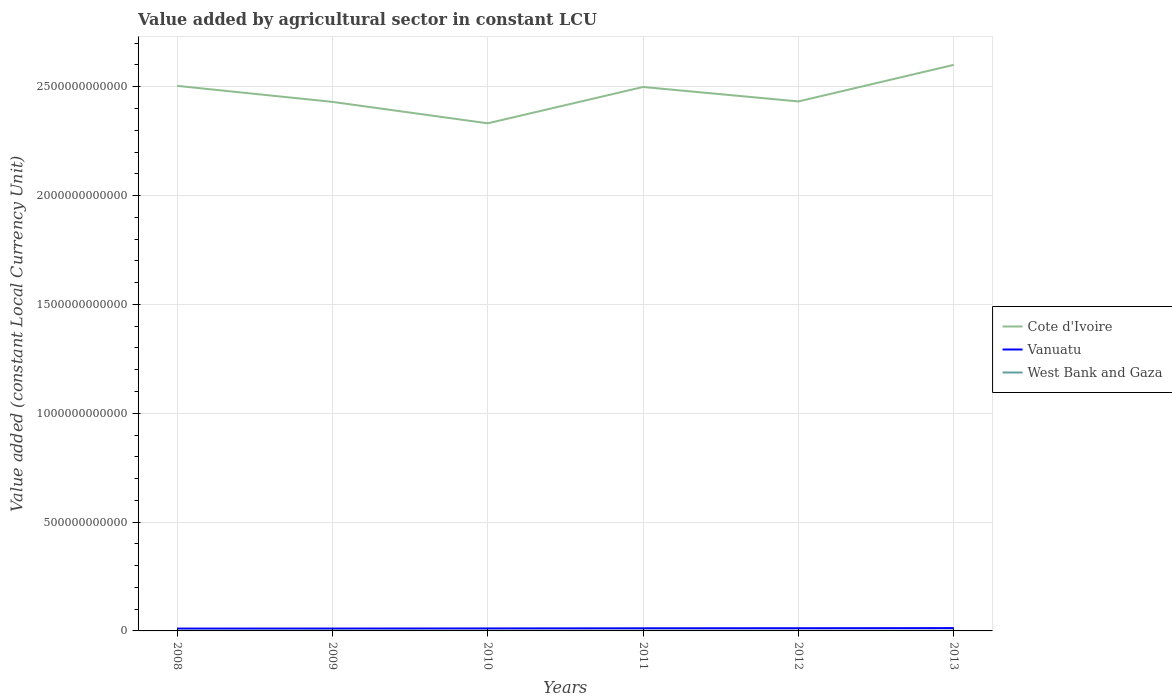Is the number of lines equal to the number of legend labels?
Give a very brief answer. Yes. Across all years, what is the maximum value added by agricultural sector in West Bank and Gaza?
Keep it short and to the point. 1.12e+09. What is the total value added by agricultural sector in Vanuatu in the graph?
Give a very brief answer. -1.56e+09. What is the difference between the highest and the second highest value added by agricultural sector in West Bank and Gaza?
Offer a terse response. 3.44e+08. Is the value added by agricultural sector in Cote d'Ivoire strictly greater than the value added by agricultural sector in Vanuatu over the years?
Provide a short and direct response. No. How many years are there in the graph?
Give a very brief answer. 6. What is the difference between two consecutive major ticks on the Y-axis?
Keep it short and to the point. 5.00e+11. Does the graph contain any zero values?
Keep it short and to the point. No. Does the graph contain grids?
Make the answer very short. Yes. Where does the legend appear in the graph?
Provide a short and direct response. Center right. How are the legend labels stacked?
Your response must be concise. Vertical. What is the title of the graph?
Offer a very short reply. Value added by agricultural sector in constant LCU. Does "Vietnam" appear as one of the legend labels in the graph?
Ensure brevity in your answer.  No. What is the label or title of the Y-axis?
Provide a succinct answer. Value added (constant Local Currency Unit). What is the Value added (constant Local Currency Unit) in Cote d'Ivoire in 2008?
Ensure brevity in your answer.  2.50e+12. What is the Value added (constant Local Currency Unit) in Vanuatu in 2008?
Ensure brevity in your answer.  1.08e+1. What is the Value added (constant Local Currency Unit) in West Bank and Gaza in 2008?
Your response must be concise. 1.19e+09. What is the Value added (constant Local Currency Unit) of Cote d'Ivoire in 2009?
Provide a short and direct response. 2.43e+12. What is the Value added (constant Local Currency Unit) in Vanuatu in 2009?
Offer a terse response. 1.09e+1. What is the Value added (constant Local Currency Unit) in West Bank and Gaza in 2009?
Make the answer very short. 1.37e+09. What is the Value added (constant Local Currency Unit) of Cote d'Ivoire in 2010?
Offer a very short reply. 2.33e+12. What is the Value added (constant Local Currency Unit) of Vanuatu in 2010?
Offer a terse response. 1.14e+1. What is the Value added (constant Local Currency Unit) of West Bank and Gaza in 2010?
Offer a terse response. 1.24e+09. What is the Value added (constant Local Currency Unit) in Cote d'Ivoire in 2011?
Ensure brevity in your answer.  2.50e+12. What is the Value added (constant Local Currency Unit) in Vanuatu in 2011?
Offer a terse response. 1.21e+1. What is the Value added (constant Local Currency Unit) of West Bank and Gaza in 2011?
Make the answer very short. 1.46e+09. What is the Value added (constant Local Currency Unit) in Cote d'Ivoire in 2012?
Ensure brevity in your answer.  2.43e+12. What is the Value added (constant Local Currency Unit) of Vanuatu in 2012?
Offer a very short reply. 1.24e+1. What is the Value added (constant Local Currency Unit) in West Bank and Gaza in 2012?
Your answer should be very brief. 1.31e+09. What is the Value added (constant Local Currency Unit) in Cote d'Ivoire in 2013?
Offer a terse response. 2.60e+12. What is the Value added (constant Local Currency Unit) of Vanuatu in 2013?
Provide a short and direct response. 1.30e+1. What is the Value added (constant Local Currency Unit) of West Bank and Gaza in 2013?
Your response must be concise. 1.12e+09. Across all years, what is the maximum Value added (constant Local Currency Unit) of Cote d'Ivoire?
Keep it short and to the point. 2.60e+12. Across all years, what is the maximum Value added (constant Local Currency Unit) in Vanuatu?
Keep it short and to the point. 1.30e+1. Across all years, what is the maximum Value added (constant Local Currency Unit) in West Bank and Gaza?
Ensure brevity in your answer.  1.46e+09. Across all years, what is the minimum Value added (constant Local Currency Unit) of Cote d'Ivoire?
Offer a very short reply. 2.33e+12. Across all years, what is the minimum Value added (constant Local Currency Unit) of Vanuatu?
Make the answer very short. 1.08e+1. Across all years, what is the minimum Value added (constant Local Currency Unit) of West Bank and Gaza?
Your response must be concise. 1.12e+09. What is the total Value added (constant Local Currency Unit) of Cote d'Ivoire in the graph?
Provide a succinct answer. 1.48e+13. What is the total Value added (constant Local Currency Unit) of Vanuatu in the graph?
Your answer should be compact. 7.06e+1. What is the total Value added (constant Local Currency Unit) of West Bank and Gaza in the graph?
Offer a terse response. 7.69e+09. What is the difference between the Value added (constant Local Currency Unit) of Cote d'Ivoire in 2008 and that in 2009?
Your answer should be very brief. 7.36e+1. What is the difference between the Value added (constant Local Currency Unit) in Vanuatu in 2008 and that in 2009?
Give a very brief answer. -7.10e+07. What is the difference between the Value added (constant Local Currency Unit) of West Bank and Gaza in 2008 and that in 2009?
Your answer should be compact. -1.77e+08. What is the difference between the Value added (constant Local Currency Unit) in Cote d'Ivoire in 2008 and that in 2010?
Give a very brief answer. 1.72e+11. What is the difference between the Value added (constant Local Currency Unit) of Vanuatu in 2008 and that in 2010?
Ensure brevity in your answer.  -5.96e+08. What is the difference between the Value added (constant Local Currency Unit) in West Bank and Gaza in 2008 and that in 2010?
Provide a succinct answer. -4.91e+07. What is the difference between the Value added (constant Local Currency Unit) of Cote d'Ivoire in 2008 and that in 2011?
Give a very brief answer. 5.21e+09. What is the difference between the Value added (constant Local Currency Unit) of Vanuatu in 2008 and that in 2011?
Give a very brief answer. -1.29e+09. What is the difference between the Value added (constant Local Currency Unit) in West Bank and Gaza in 2008 and that in 2011?
Ensure brevity in your answer.  -2.71e+08. What is the difference between the Value added (constant Local Currency Unit) of Cote d'Ivoire in 2008 and that in 2012?
Your response must be concise. 7.16e+1. What is the difference between the Value added (constant Local Currency Unit) in Vanuatu in 2008 and that in 2012?
Give a very brief answer. -1.56e+09. What is the difference between the Value added (constant Local Currency Unit) in West Bank and Gaza in 2008 and that in 2012?
Provide a succinct answer. -1.13e+08. What is the difference between the Value added (constant Local Currency Unit) of Cote d'Ivoire in 2008 and that in 2013?
Offer a very short reply. -9.64e+1. What is the difference between the Value added (constant Local Currency Unit) in Vanuatu in 2008 and that in 2013?
Provide a succinct answer. -2.15e+09. What is the difference between the Value added (constant Local Currency Unit) in West Bank and Gaza in 2008 and that in 2013?
Your answer should be very brief. 7.39e+07. What is the difference between the Value added (constant Local Currency Unit) in Cote d'Ivoire in 2009 and that in 2010?
Provide a succinct answer. 9.84e+1. What is the difference between the Value added (constant Local Currency Unit) in Vanuatu in 2009 and that in 2010?
Make the answer very short. -5.25e+08. What is the difference between the Value added (constant Local Currency Unit) in West Bank and Gaza in 2009 and that in 2010?
Your answer should be compact. 1.27e+08. What is the difference between the Value added (constant Local Currency Unit) of Cote d'Ivoire in 2009 and that in 2011?
Provide a short and direct response. -6.84e+1. What is the difference between the Value added (constant Local Currency Unit) in Vanuatu in 2009 and that in 2011?
Your response must be concise. -1.22e+09. What is the difference between the Value added (constant Local Currency Unit) in West Bank and Gaza in 2009 and that in 2011?
Your answer should be very brief. -9.40e+07. What is the difference between the Value added (constant Local Currency Unit) of Cote d'Ivoire in 2009 and that in 2012?
Your answer should be very brief. -2.03e+09. What is the difference between the Value added (constant Local Currency Unit) in Vanuatu in 2009 and that in 2012?
Provide a succinct answer. -1.49e+09. What is the difference between the Value added (constant Local Currency Unit) in West Bank and Gaza in 2009 and that in 2012?
Provide a succinct answer. 6.36e+07. What is the difference between the Value added (constant Local Currency Unit) of Cote d'Ivoire in 2009 and that in 2013?
Ensure brevity in your answer.  -1.70e+11. What is the difference between the Value added (constant Local Currency Unit) of Vanuatu in 2009 and that in 2013?
Offer a terse response. -2.08e+09. What is the difference between the Value added (constant Local Currency Unit) in West Bank and Gaza in 2009 and that in 2013?
Provide a short and direct response. 2.50e+08. What is the difference between the Value added (constant Local Currency Unit) of Cote d'Ivoire in 2010 and that in 2011?
Your response must be concise. -1.67e+11. What is the difference between the Value added (constant Local Currency Unit) in Vanuatu in 2010 and that in 2011?
Your response must be concise. -6.93e+08. What is the difference between the Value added (constant Local Currency Unit) of West Bank and Gaza in 2010 and that in 2011?
Offer a terse response. -2.21e+08. What is the difference between the Value added (constant Local Currency Unit) of Cote d'Ivoire in 2010 and that in 2012?
Make the answer very short. -1.00e+11. What is the difference between the Value added (constant Local Currency Unit) in Vanuatu in 2010 and that in 2012?
Ensure brevity in your answer.  -9.62e+08. What is the difference between the Value added (constant Local Currency Unit) in West Bank and Gaza in 2010 and that in 2012?
Your answer should be very brief. -6.38e+07. What is the difference between the Value added (constant Local Currency Unit) of Cote d'Ivoire in 2010 and that in 2013?
Provide a short and direct response. -2.68e+11. What is the difference between the Value added (constant Local Currency Unit) of Vanuatu in 2010 and that in 2013?
Ensure brevity in your answer.  -1.55e+09. What is the difference between the Value added (constant Local Currency Unit) of West Bank and Gaza in 2010 and that in 2013?
Give a very brief answer. 1.23e+08. What is the difference between the Value added (constant Local Currency Unit) in Cote d'Ivoire in 2011 and that in 2012?
Keep it short and to the point. 6.64e+1. What is the difference between the Value added (constant Local Currency Unit) of Vanuatu in 2011 and that in 2012?
Provide a short and direct response. -2.69e+08. What is the difference between the Value added (constant Local Currency Unit) of West Bank and Gaza in 2011 and that in 2012?
Ensure brevity in your answer.  1.58e+08. What is the difference between the Value added (constant Local Currency Unit) in Cote d'Ivoire in 2011 and that in 2013?
Make the answer very short. -1.02e+11. What is the difference between the Value added (constant Local Currency Unit) in Vanuatu in 2011 and that in 2013?
Provide a succinct answer. -8.61e+08. What is the difference between the Value added (constant Local Currency Unit) in West Bank and Gaza in 2011 and that in 2013?
Make the answer very short. 3.44e+08. What is the difference between the Value added (constant Local Currency Unit) in Cote d'Ivoire in 2012 and that in 2013?
Give a very brief answer. -1.68e+11. What is the difference between the Value added (constant Local Currency Unit) of Vanuatu in 2012 and that in 2013?
Offer a very short reply. -5.92e+08. What is the difference between the Value added (constant Local Currency Unit) in West Bank and Gaza in 2012 and that in 2013?
Give a very brief answer. 1.87e+08. What is the difference between the Value added (constant Local Currency Unit) in Cote d'Ivoire in 2008 and the Value added (constant Local Currency Unit) in Vanuatu in 2009?
Make the answer very short. 2.49e+12. What is the difference between the Value added (constant Local Currency Unit) in Cote d'Ivoire in 2008 and the Value added (constant Local Currency Unit) in West Bank and Gaza in 2009?
Ensure brevity in your answer.  2.50e+12. What is the difference between the Value added (constant Local Currency Unit) in Vanuatu in 2008 and the Value added (constant Local Currency Unit) in West Bank and Gaza in 2009?
Your answer should be very brief. 9.46e+09. What is the difference between the Value added (constant Local Currency Unit) in Cote d'Ivoire in 2008 and the Value added (constant Local Currency Unit) in Vanuatu in 2010?
Offer a very short reply. 2.49e+12. What is the difference between the Value added (constant Local Currency Unit) of Cote d'Ivoire in 2008 and the Value added (constant Local Currency Unit) of West Bank and Gaza in 2010?
Your answer should be compact. 2.50e+12. What is the difference between the Value added (constant Local Currency Unit) of Vanuatu in 2008 and the Value added (constant Local Currency Unit) of West Bank and Gaza in 2010?
Keep it short and to the point. 9.59e+09. What is the difference between the Value added (constant Local Currency Unit) in Cote d'Ivoire in 2008 and the Value added (constant Local Currency Unit) in Vanuatu in 2011?
Provide a succinct answer. 2.49e+12. What is the difference between the Value added (constant Local Currency Unit) in Cote d'Ivoire in 2008 and the Value added (constant Local Currency Unit) in West Bank and Gaza in 2011?
Provide a short and direct response. 2.50e+12. What is the difference between the Value added (constant Local Currency Unit) of Vanuatu in 2008 and the Value added (constant Local Currency Unit) of West Bank and Gaza in 2011?
Your answer should be very brief. 9.36e+09. What is the difference between the Value added (constant Local Currency Unit) of Cote d'Ivoire in 2008 and the Value added (constant Local Currency Unit) of Vanuatu in 2012?
Your answer should be compact. 2.49e+12. What is the difference between the Value added (constant Local Currency Unit) of Cote d'Ivoire in 2008 and the Value added (constant Local Currency Unit) of West Bank and Gaza in 2012?
Make the answer very short. 2.50e+12. What is the difference between the Value added (constant Local Currency Unit) of Vanuatu in 2008 and the Value added (constant Local Currency Unit) of West Bank and Gaza in 2012?
Make the answer very short. 9.52e+09. What is the difference between the Value added (constant Local Currency Unit) of Cote d'Ivoire in 2008 and the Value added (constant Local Currency Unit) of Vanuatu in 2013?
Offer a terse response. 2.49e+12. What is the difference between the Value added (constant Local Currency Unit) of Cote d'Ivoire in 2008 and the Value added (constant Local Currency Unit) of West Bank and Gaza in 2013?
Ensure brevity in your answer.  2.50e+12. What is the difference between the Value added (constant Local Currency Unit) of Vanuatu in 2008 and the Value added (constant Local Currency Unit) of West Bank and Gaza in 2013?
Give a very brief answer. 9.71e+09. What is the difference between the Value added (constant Local Currency Unit) in Cote d'Ivoire in 2009 and the Value added (constant Local Currency Unit) in Vanuatu in 2010?
Ensure brevity in your answer.  2.42e+12. What is the difference between the Value added (constant Local Currency Unit) in Cote d'Ivoire in 2009 and the Value added (constant Local Currency Unit) in West Bank and Gaza in 2010?
Provide a short and direct response. 2.43e+12. What is the difference between the Value added (constant Local Currency Unit) of Vanuatu in 2009 and the Value added (constant Local Currency Unit) of West Bank and Gaza in 2010?
Your answer should be very brief. 9.66e+09. What is the difference between the Value added (constant Local Currency Unit) in Cote d'Ivoire in 2009 and the Value added (constant Local Currency Unit) in Vanuatu in 2011?
Keep it short and to the point. 2.42e+12. What is the difference between the Value added (constant Local Currency Unit) in Cote d'Ivoire in 2009 and the Value added (constant Local Currency Unit) in West Bank and Gaza in 2011?
Make the answer very short. 2.43e+12. What is the difference between the Value added (constant Local Currency Unit) in Vanuatu in 2009 and the Value added (constant Local Currency Unit) in West Bank and Gaza in 2011?
Your response must be concise. 9.44e+09. What is the difference between the Value added (constant Local Currency Unit) of Cote d'Ivoire in 2009 and the Value added (constant Local Currency Unit) of Vanuatu in 2012?
Keep it short and to the point. 2.42e+12. What is the difference between the Value added (constant Local Currency Unit) of Cote d'Ivoire in 2009 and the Value added (constant Local Currency Unit) of West Bank and Gaza in 2012?
Your response must be concise. 2.43e+12. What is the difference between the Value added (constant Local Currency Unit) in Vanuatu in 2009 and the Value added (constant Local Currency Unit) in West Bank and Gaza in 2012?
Your answer should be compact. 9.59e+09. What is the difference between the Value added (constant Local Currency Unit) in Cote d'Ivoire in 2009 and the Value added (constant Local Currency Unit) in Vanuatu in 2013?
Provide a succinct answer. 2.42e+12. What is the difference between the Value added (constant Local Currency Unit) of Cote d'Ivoire in 2009 and the Value added (constant Local Currency Unit) of West Bank and Gaza in 2013?
Your answer should be compact. 2.43e+12. What is the difference between the Value added (constant Local Currency Unit) in Vanuatu in 2009 and the Value added (constant Local Currency Unit) in West Bank and Gaza in 2013?
Provide a succinct answer. 9.78e+09. What is the difference between the Value added (constant Local Currency Unit) of Cote d'Ivoire in 2010 and the Value added (constant Local Currency Unit) of Vanuatu in 2011?
Your answer should be compact. 2.32e+12. What is the difference between the Value added (constant Local Currency Unit) in Cote d'Ivoire in 2010 and the Value added (constant Local Currency Unit) in West Bank and Gaza in 2011?
Provide a short and direct response. 2.33e+12. What is the difference between the Value added (constant Local Currency Unit) in Vanuatu in 2010 and the Value added (constant Local Currency Unit) in West Bank and Gaza in 2011?
Your answer should be very brief. 9.96e+09. What is the difference between the Value added (constant Local Currency Unit) of Cote d'Ivoire in 2010 and the Value added (constant Local Currency Unit) of Vanuatu in 2012?
Your answer should be compact. 2.32e+12. What is the difference between the Value added (constant Local Currency Unit) of Cote d'Ivoire in 2010 and the Value added (constant Local Currency Unit) of West Bank and Gaza in 2012?
Provide a succinct answer. 2.33e+12. What is the difference between the Value added (constant Local Currency Unit) of Vanuatu in 2010 and the Value added (constant Local Currency Unit) of West Bank and Gaza in 2012?
Offer a terse response. 1.01e+1. What is the difference between the Value added (constant Local Currency Unit) of Cote d'Ivoire in 2010 and the Value added (constant Local Currency Unit) of Vanuatu in 2013?
Give a very brief answer. 2.32e+12. What is the difference between the Value added (constant Local Currency Unit) in Cote d'Ivoire in 2010 and the Value added (constant Local Currency Unit) in West Bank and Gaza in 2013?
Make the answer very short. 2.33e+12. What is the difference between the Value added (constant Local Currency Unit) in Vanuatu in 2010 and the Value added (constant Local Currency Unit) in West Bank and Gaza in 2013?
Your answer should be very brief. 1.03e+1. What is the difference between the Value added (constant Local Currency Unit) in Cote d'Ivoire in 2011 and the Value added (constant Local Currency Unit) in Vanuatu in 2012?
Keep it short and to the point. 2.49e+12. What is the difference between the Value added (constant Local Currency Unit) of Cote d'Ivoire in 2011 and the Value added (constant Local Currency Unit) of West Bank and Gaza in 2012?
Provide a succinct answer. 2.50e+12. What is the difference between the Value added (constant Local Currency Unit) of Vanuatu in 2011 and the Value added (constant Local Currency Unit) of West Bank and Gaza in 2012?
Offer a very short reply. 1.08e+1. What is the difference between the Value added (constant Local Currency Unit) of Cote d'Ivoire in 2011 and the Value added (constant Local Currency Unit) of Vanuatu in 2013?
Your answer should be compact. 2.49e+12. What is the difference between the Value added (constant Local Currency Unit) in Cote d'Ivoire in 2011 and the Value added (constant Local Currency Unit) in West Bank and Gaza in 2013?
Your response must be concise. 2.50e+12. What is the difference between the Value added (constant Local Currency Unit) in Vanuatu in 2011 and the Value added (constant Local Currency Unit) in West Bank and Gaza in 2013?
Keep it short and to the point. 1.10e+1. What is the difference between the Value added (constant Local Currency Unit) in Cote d'Ivoire in 2012 and the Value added (constant Local Currency Unit) in Vanuatu in 2013?
Provide a succinct answer. 2.42e+12. What is the difference between the Value added (constant Local Currency Unit) of Cote d'Ivoire in 2012 and the Value added (constant Local Currency Unit) of West Bank and Gaza in 2013?
Offer a terse response. 2.43e+12. What is the difference between the Value added (constant Local Currency Unit) of Vanuatu in 2012 and the Value added (constant Local Currency Unit) of West Bank and Gaza in 2013?
Your response must be concise. 1.13e+1. What is the average Value added (constant Local Currency Unit) in Cote d'Ivoire per year?
Your response must be concise. 2.47e+12. What is the average Value added (constant Local Currency Unit) of Vanuatu per year?
Provide a short and direct response. 1.18e+1. What is the average Value added (constant Local Currency Unit) of West Bank and Gaza per year?
Your answer should be very brief. 1.28e+09. In the year 2008, what is the difference between the Value added (constant Local Currency Unit) of Cote d'Ivoire and Value added (constant Local Currency Unit) of Vanuatu?
Your response must be concise. 2.49e+12. In the year 2008, what is the difference between the Value added (constant Local Currency Unit) in Cote d'Ivoire and Value added (constant Local Currency Unit) in West Bank and Gaza?
Your answer should be very brief. 2.50e+12. In the year 2008, what is the difference between the Value added (constant Local Currency Unit) in Vanuatu and Value added (constant Local Currency Unit) in West Bank and Gaza?
Make the answer very short. 9.64e+09. In the year 2009, what is the difference between the Value added (constant Local Currency Unit) in Cote d'Ivoire and Value added (constant Local Currency Unit) in Vanuatu?
Ensure brevity in your answer.  2.42e+12. In the year 2009, what is the difference between the Value added (constant Local Currency Unit) in Cote d'Ivoire and Value added (constant Local Currency Unit) in West Bank and Gaza?
Provide a succinct answer. 2.43e+12. In the year 2009, what is the difference between the Value added (constant Local Currency Unit) of Vanuatu and Value added (constant Local Currency Unit) of West Bank and Gaza?
Offer a terse response. 9.53e+09. In the year 2010, what is the difference between the Value added (constant Local Currency Unit) in Cote d'Ivoire and Value added (constant Local Currency Unit) in Vanuatu?
Provide a short and direct response. 2.32e+12. In the year 2010, what is the difference between the Value added (constant Local Currency Unit) of Cote d'Ivoire and Value added (constant Local Currency Unit) of West Bank and Gaza?
Provide a short and direct response. 2.33e+12. In the year 2010, what is the difference between the Value added (constant Local Currency Unit) in Vanuatu and Value added (constant Local Currency Unit) in West Bank and Gaza?
Give a very brief answer. 1.02e+1. In the year 2011, what is the difference between the Value added (constant Local Currency Unit) of Cote d'Ivoire and Value added (constant Local Currency Unit) of Vanuatu?
Provide a short and direct response. 2.49e+12. In the year 2011, what is the difference between the Value added (constant Local Currency Unit) of Cote d'Ivoire and Value added (constant Local Currency Unit) of West Bank and Gaza?
Offer a very short reply. 2.50e+12. In the year 2011, what is the difference between the Value added (constant Local Currency Unit) of Vanuatu and Value added (constant Local Currency Unit) of West Bank and Gaza?
Give a very brief answer. 1.07e+1. In the year 2012, what is the difference between the Value added (constant Local Currency Unit) in Cote d'Ivoire and Value added (constant Local Currency Unit) in Vanuatu?
Offer a terse response. 2.42e+12. In the year 2012, what is the difference between the Value added (constant Local Currency Unit) in Cote d'Ivoire and Value added (constant Local Currency Unit) in West Bank and Gaza?
Your answer should be very brief. 2.43e+12. In the year 2012, what is the difference between the Value added (constant Local Currency Unit) in Vanuatu and Value added (constant Local Currency Unit) in West Bank and Gaza?
Provide a short and direct response. 1.11e+1. In the year 2013, what is the difference between the Value added (constant Local Currency Unit) in Cote d'Ivoire and Value added (constant Local Currency Unit) in Vanuatu?
Give a very brief answer. 2.59e+12. In the year 2013, what is the difference between the Value added (constant Local Currency Unit) of Cote d'Ivoire and Value added (constant Local Currency Unit) of West Bank and Gaza?
Provide a short and direct response. 2.60e+12. In the year 2013, what is the difference between the Value added (constant Local Currency Unit) in Vanuatu and Value added (constant Local Currency Unit) in West Bank and Gaza?
Your answer should be compact. 1.19e+1. What is the ratio of the Value added (constant Local Currency Unit) in Cote d'Ivoire in 2008 to that in 2009?
Provide a succinct answer. 1.03. What is the ratio of the Value added (constant Local Currency Unit) in Vanuatu in 2008 to that in 2009?
Your answer should be very brief. 0.99. What is the ratio of the Value added (constant Local Currency Unit) of West Bank and Gaza in 2008 to that in 2009?
Make the answer very short. 0.87. What is the ratio of the Value added (constant Local Currency Unit) of Cote d'Ivoire in 2008 to that in 2010?
Provide a short and direct response. 1.07. What is the ratio of the Value added (constant Local Currency Unit) in Vanuatu in 2008 to that in 2010?
Your response must be concise. 0.95. What is the ratio of the Value added (constant Local Currency Unit) in West Bank and Gaza in 2008 to that in 2010?
Provide a short and direct response. 0.96. What is the ratio of the Value added (constant Local Currency Unit) in Cote d'Ivoire in 2008 to that in 2011?
Offer a terse response. 1. What is the ratio of the Value added (constant Local Currency Unit) in Vanuatu in 2008 to that in 2011?
Offer a very short reply. 0.89. What is the ratio of the Value added (constant Local Currency Unit) in West Bank and Gaza in 2008 to that in 2011?
Your answer should be very brief. 0.82. What is the ratio of the Value added (constant Local Currency Unit) of Cote d'Ivoire in 2008 to that in 2012?
Provide a short and direct response. 1.03. What is the ratio of the Value added (constant Local Currency Unit) of Vanuatu in 2008 to that in 2012?
Your answer should be compact. 0.87. What is the ratio of the Value added (constant Local Currency Unit) in West Bank and Gaza in 2008 to that in 2012?
Offer a very short reply. 0.91. What is the ratio of the Value added (constant Local Currency Unit) in Cote d'Ivoire in 2008 to that in 2013?
Ensure brevity in your answer.  0.96. What is the ratio of the Value added (constant Local Currency Unit) of Vanuatu in 2008 to that in 2013?
Ensure brevity in your answer.  0.83. What is the ratio of the Value added (constant Local Currency Unit) of West Bank and Gaza in 2008 to that in 2013?
Provide a succinct answer. 1.07. What is the ratio of the Value added (constant Local Currency Unit) in Cote d'Ivoire in 2009 to that in 2010?
Your answer should be compact. 1.04. What is the ratio of the Value added (constant Local Currency Unit) of Vanuatu in 2009 to that in 2010?
Offer a very short reply. 0.95. What is the ratio of the Value added (constant Local Currency Unit) of West Bank and Gaza in 2009 to that in 2010?
Give a very brief answer. 1.1. What is the ratio of the Value added (constant Local Currency Unit) of Cote d'Ivoire in 2009 to that in 2011?
Your response must be concise. 0.97. What is the ratio of the Value added (constant Local Currency Unit) of Vanuatu in 2009 to that in 2011?
Give a very brief answer. 0.9. What is the ratio of the Value added (constant Local Currency Unit) of West Bank and Gaza in 2009 to that in 2011?
Provide a succinct answer. 0.94. What is the ratio of the Value added (constant Local Currency Unit) of Cote d'Ivoire in 2009 to that in 2012?
Make the answer very short. 1. What is the ratio of the Value added (constant Local Currency Unit) in Vanuatu in 2009 to that in 2012?
Provide a short and direct response. 0.88. What is the ratio of the Value added (constant Local Currency Unit) of West Bank and Gaza in 2009 to that in 2012?
Offer a very short reply. 1.05. What is the ratio of the Value added (constant Local Currency Unit) of Cote d'Ivoire in 2009 to that in 2013?
Ensure brevity in your answer.  0.93. What is the ratio of the Value added (constant Local Currency Unit) in Vanuatu in 2009 to that in 2013?
Provide a short and direct response. 0.84. What is the ratio of the Value added (constant Local Currency Unit) of West Bank and Gaza in 2009 to that in 2013?
Keep it short and to the point. 1.22. What is the ratio of the Value added (constant Local Currency Unit) of Cote d'Ivoire in 2010 to that in 2011?
Your answer should be very brief. 0.93. What is the ratio of the Value added (constant Local Currency Unit) in Vanuatu in 2010 to that in 2011?
Give a very brief answer. 0.94. What is the ratio of the Value added (constant Local Currency Unit) in West Bank and Gaza in 2010 to that in 2011?
Your answer should be compact. 0.85. What is the ratio of the Value added (constant Local Currency Unit) in Cote d'Ivoire in 2010 to that in 2012?
Ensure brevity in your answer.  0.96. What is the ratio of the Value added (constant Local Currency Unit) in Vanuatu in 2010 to that in 2012?
Make the answer very short. 0.92. What is the ratio of the Value added (constant Local Currency Unit) in West Bank and Gaza in 2010 to that in 2012?
Offer a very short reply. 0.95. What is the ratio of the Value added (constant Local Currency Unit) in Cote d'Ivoire in 2010 to that in 2013?
Give a very brief answer. 0.9. What is the ratio of the Value added (constant Local Currency Unit) of Vanuatu in 2010 to that in 2013?
Provide a succinct answer. 0.88. What is the ratio of the Value added (constant Local Currency Unit) in West Bank and Gaza in 2010 to that in 2013?
Give a very brief answer. 1.11. What is the ratio of the Value added (constant Local Currency Unit) of Cote d'Ivoire in 2011 to that in 2012?
Offer a very short reply. 1.03. What is the ratio of the Value added (constant Local Currency Unit) of Vanuatu in 2011 to that in 2012?
Offer a terse response. 0.98. What is the ratio of the Value added (constant Local Currency Unit) in West Bank and Gaza in 2011 to that in 2012?
Provide a succinct answer. 1.12. What is the ratio of the Value added (constant Local Currency Unit) in Cote d'Ivoire in 2011 to that in 2013?
Your answer should be compact. 0.96. What is the ratio of the Value added (constant Local Currency Unit) in Vanuatu in 2011 to that in 2013?
Your answer should be very brief. 0.93. What is the ratio of the Value added (constant Local Currency Unit) in West Bank and Gaza in 2011 to that in 2013?
Provide a succinct answer. 1.31. What is the ratio of the Value added (constant Local Currency Unit) of Cote d'Ivoire in 2012 to that in 2013?
Make the answer very short. 0.94. What is the ratio of the Value added (constant Local Currency Unit) of Vanuatu in 2012 to that in 2013?
Ensure brevity in your answer.  0.95. What is the ratio of the Value added (constant Local Currency Unit) in West Bank and Gaza in 2012 to that in 2013?
Keep it short and to the point. 1.17. What is the difference between the highest and the second highest Value added (constant Local Currency Unit) in Cote d'Ivoire?
Your answer should be compact. 9.64e+1. What is the difference between the highest and the second highest Value added (constant Local Currency Unit) in Vanuatu?
Give a very brief answer. 5.92e+08. What is the difference between the highest and the second highest Value added (constant Local Currency Unit) in West Bank and Gaza?
Make the answer very short. 9.40e+07. What is the difference between the highest and the lowest Value added (constant Local Currency Unit) in Cote d'Ivoire?
Your answer should be very brief. 2.68e+11. What is the difference between the highest and the lowest Value added (constant Local Currency Unit) in Vanuatu?
Your answer should be very brief. 2.15e+09. What is the difference between the highest and the lowest Value added (constant Local Currency Unit) of West Bank and Gaza?
Give a very brief answer. 3.44e+08. 